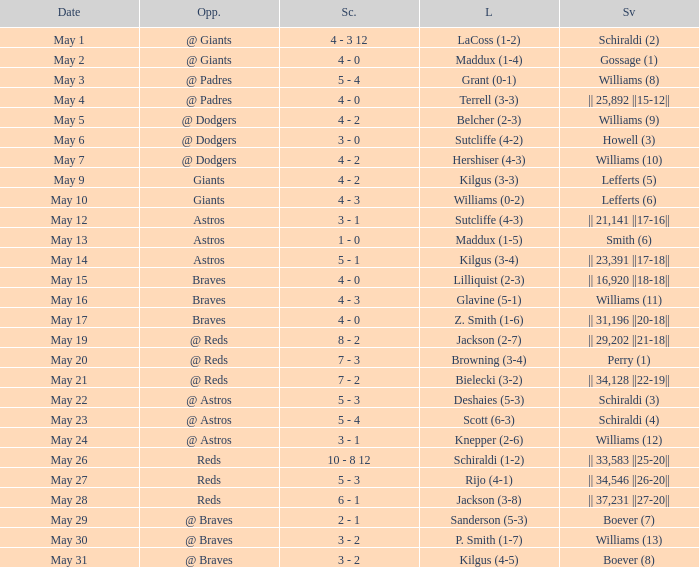Name the opponent for save of williams (9) @ Dodgers. 